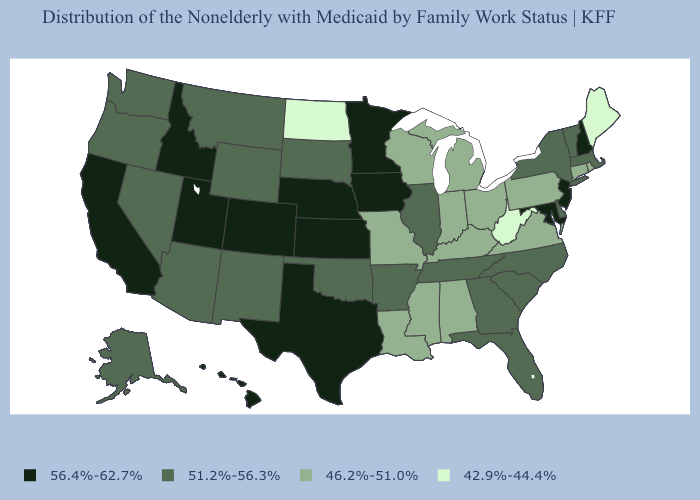What is the value of Minnesota?
Be succinct. 56.4%-62.7%. Does Illinois have the same value as Hawaii?
Short answer required. No. Which states have the highest value in the USA?
Concise answer only. California, Colorado, Hawaii, Idaho, Iowa, Kansas, Maryland, Minnesota, Nebraska, New Hampshire, New Jersey, Texas, Utah. Name the states that have a value in the range 46.2%-51.0%?
Write a very short answer. Alabama, Connecticut, Indiana, Kentucky, Louisiana, Michigan, Mississippi, Missouri, Ohio, Pennsylvania, Rhode Island, Virginia, Wisconsin. Does the map have missing data?
Write a very short answer. No. Does Texas have the highest value in the USA?
Quick response, please. Yes. Name the states that have a value in the range 42.9%-44.4%?
Short answer required. Maine, North Dakota, West Virginia. Name the states that have a value in the range 42.9%-44.4%?
Concise answer only. Maine, North Dakota, West Virginia. Which states have the highest value in the USA?
Concise answer only. California, Colorado, Hawaii, Idaho, Iowa, Kansas, Maryland, Minnesota, Nebraska, New Hampshire, New Jersey, Texas, Utah. Is the legend a continuous bar?
Write a very short answer. No. Among the states that border Rhode Island , which have the lowest value?
Quick response, please. Connecticut. Does Hawaii have the highest value in the West?
Give a very brief answer. Yes. Name the states that have a value in the range 56.4%-62.7%?
Be succinct. California, Colorado, Hawaii, Idaho, Iowa, Kansas, Maryland, Minnesota, Nebraska, New Hampshire, New Jersey, Texas, Utah. Does New Hampshire have a higher value than Washington?
Answer briefly. Yes. Which states have the lowest value in the USA?
Give a very brief answer. Maine, North Dakota, West Virginia. 